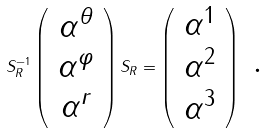Convert formula to latex. <formula><loc_0><loc_0><loc_500><loc_500>S _ { R } ^ { - 1 } \left ( \begin{array} { c } \alpha ^ { \theta } \\ \alpha ^ { \varphi } \\ \alpha ^ { r } \end{array} \right ) S _ { R } = \left ( \begin{array} { c } \alpha ^ { 1 } \\ \alpha ^ { 2 } \\ \alpha ^ { 3 } \end{array} \right ) \text { .}</formula> 